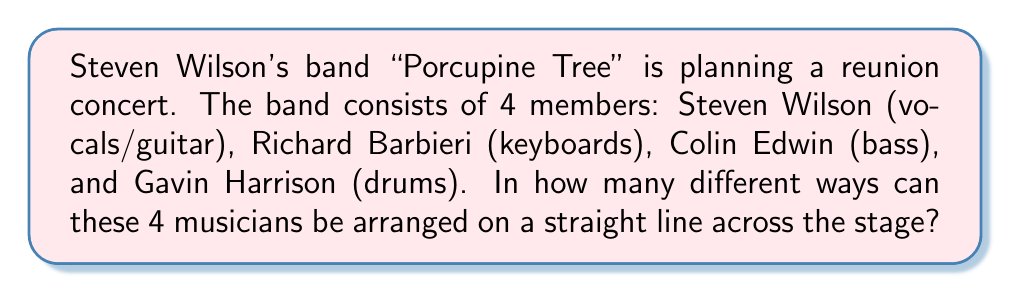What is the answer to this math problem? Let's approach this step-by-step:

1) This is a permutation problem. We need to arrange 4 distinct musicians in a line.

2) For the first position, we have 4 choices (any of the 4 musicians can be first).

3) After placing the first musician, we have 3 choices for the second position.

4) For the third position, we have 2 choices left.

5) For the last position, we only have 1 choice (the remaining musician).

6) According to the multiplication principle, we multiply these numbers:

   $$ 4 \times 3 \times 2 \times 1 = 24 $$

7) This is also known as 4 factorial, written as 4!:

   $$ 4! = 4 \times 3 \times 2 \times 1 = 24 $$

Therefore, there are 24 different ways to arrange the 4 musicians on the stage.
Answer: 24 